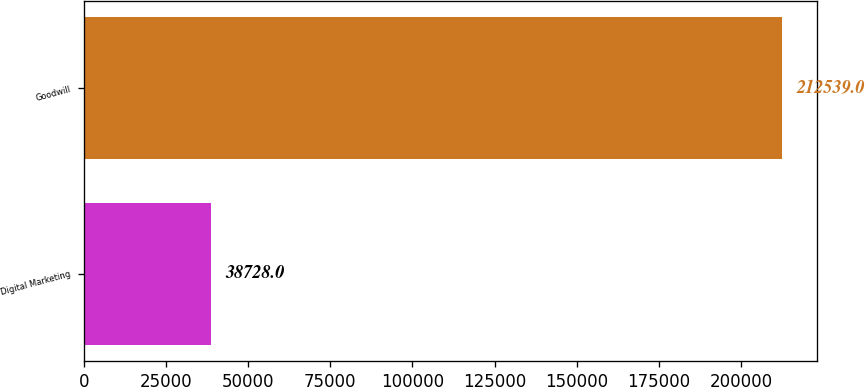<chart> <loc_0><loc_0><loc_500><loc_500><bar_chart><fcel>Digital Marketing<fcel>Goodwill<nl><fcel>38728<fcel>212539<nl></chart> 